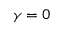<formula> <loc_0><loc_0><loc_500><loc_500>\gamma = 0</formula> 